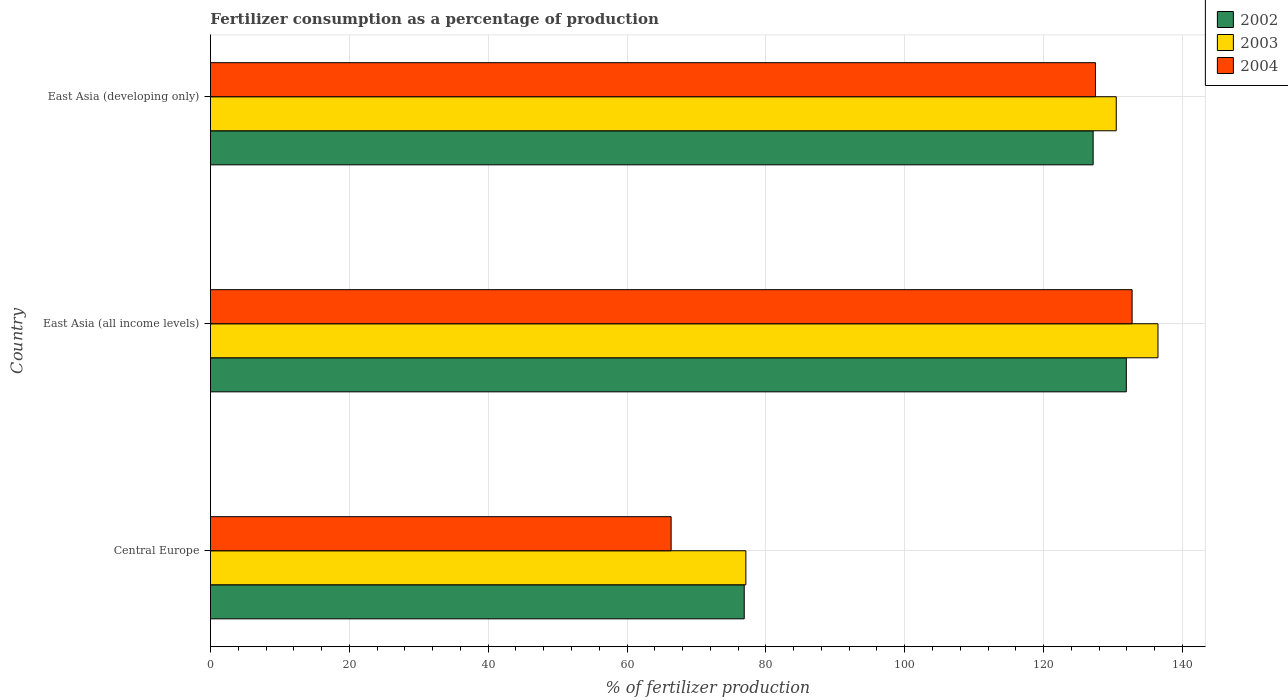How many groups of bars are there?
Offer a terse response. 3. Are the number of bars on each tick of the Y-axis equal?
Your answer should be very brief. Yes. How many bars are there on the 1st tick from the bottom?
Give a very brief answer. 3. What is the label of the 2nd group of bars from the top?
Offer a very short reply. East Asia (all income levels). In how many cases, is the number of bars for a given country not equal to the number of legend labels?
Provide a short and direct response. 0. What is the percentage of fertilizers consumed in 2003 in East Asia (all income levels)?
Keep it short and to the point. 136.48. Across all countries, what is the maximum percentage of fertilizers consumed in 2004?
Offer a very short reply. 132.75. Across all countries, what is the minimum percentage of fertilizers consumed in 2002?
Ensure brevity in your answer.  76.88. In which country was the percentage of fertilizers consumed in 2002 maximum?
Your answer should be compact. East Asia (all income levels). In which country was the percentage of fertilizers consumed in 2004 minimum?
Offer a terse response. Central Europe. What is the total percentage of fertilizers consumed in 2004 in the graph?
Provide a succinct answer. 326.57. What is the difference between the percentage of fertilizers consumed in 2004 in Central Europe and that in East Asia (all income levels)?
Give a very brief answer. -66.4. What is the difference between the percentage of fertilizers consumed in 2004 in East Asia (all income levels) and the percentage of fertilizers consumed in 2002 in East Asia (developing only)?
Ensure brevity in your answer.  5.61. What is the average percentage of fertilizers consumed in 2002 per country?
Offer a very short reply. 111.98. What is the difference between the percentage of fertilizers consumed in 2002 and percentage of fertilizers consumed in 2004 in Central Europe?
Provide a short and direct response. 10.53. In how many countries, is the percentage of fertilizers consumed in 2003 greater than 124 %?
Your response must be concise. 2. What is the ratio of the percentage of fertilizers consumed in 2002 in Central Europe to that in East Asia (all income levels)?
Keep it short and to the point. 0.58. Is the difference between the percentage of fertilizers consumed in 2002 in East Asia (all income levels) and East Asia (developing only) greater than the difference between the percentage of fertilizers consumed in 2004 in East Asia (all income levels) and East Asia (developing only)?
Make the answer very short. No. What is the difference between the highest and the second highest percentage of fertilizers consumed in 2004?
Keep it short and to the point. 5.28. What is the difference between the highest and the lowest percentage of fertilizers consumed in 2003?
Provide a short and direct response. 59.36. Is the sum of the percentage of fertilizers consumed in 2004 in East Asia (all income levels) and East Asia (developing only) greater than the maximum percentage of fertilizers consumed in 2003 across all countries?
Your answer should be compact. Yes. What does the 1st bar from the bottom in Central Europe represents?
Offer a very short reply. 2002. How many bars are there?
Keep it short and to the point. 9. Are the values on the major ticks of X-axis written in scientific E-notation?
Offer a very short reply. No. Does the graph contain grids?
Your response must be concise. Yes. Where does the legend appear in the graph?
Keep it short and to the point. Top right. What is the title of the graph?
Provide a short and direct response. Fertilizer consumption as a percentage of production. What is the label or title of the X-axis?
Offer a very short reply. % of fertilizer production. What is the label or title of the Y-axis?
Provide a short and direct response. Country. What is the % of fertilizer production of 2002 in Central Europe?
Offer a very short reply. 76.88. What is the % of fertilizer production of 2003 in Central Europe?
Offer a very short reply. 77.12. What is the % of fertilizer production of 2004 in Central Europe?
Your answer should be compact. 66.35. What is the % of fertilizer production of 2002 in East Asia (all income levels)?
Make the answer very short. 131.91. What is the % of fertilizer production in 2003 in East Asia (all income levels)?
Offer a terse response. 136.48. What is the % of fertilizer production in 2004 in East Asia (all income levels)?
Provide a succinct answer. 132.75. What is the % of fertilizer production in 2002 in East Asia (developing only)?
Offer a terse response. 127.14. What is the % of fertilizer production in 2003 in East Asia (developing only)?
Keep it short and to the point. 130.46. What is the % of fertilizer production in 2004 in East Asia (developing only)?
Make the answer very short. 127.47. Across all countries, what is the maximum % of fertilizer production of 2002?
Offer a terse response. 131.91. Across all countries, what is the maximum % of fertilizer production of 2003?
Your answer should be very brief. 136.48. Across all countries, what is the maximum % of fertilizer production of 2004?
Provide a short and direct response. 132.75. Across all countries, what is the minimum % of fertilizer production of 2002?
Your answer should be very brief. 76.88. Across all countries, what is the minimum % of fertilizer production in 2003?
Keep it short and to the point. 77.12. Across all countries, what is the minimum % of fertilizer production in 2004?
Give a very brief answer. 66.35. What is the total % of fertilizer production in 2002 in the graph?
Provide a short and direct response. 335.93. What is the total % of fertilizer production in 2003 in the graph?
Your response must be concise. 344.06. What is the total % of fertilizer production of 2004 in the graph?
Offer a terse response. 326.57. What is the difference between the % of fertilizer production of 2002 in Central Europe and that in East Asia (all income levels)?
Offer a terse response. -55.03. What is the difference between the % of fertilizer production in 2003 in Central Europe and that in East Asia (all income levels)?
Offer a terse response. -59.36. What is the difference between the % of fertilizer production of 2004 in Central Europe and that in East Asia (all income levels)?
Your answer should be compact. -66.4. What is the difference between the % of fertilizer production in 2002 in Central Europe and that in East Asia (developing only)?
Keep it short and to the point. -50.26. What is the difference between the % of fertilizer production in 2003 in Central Europe and that in East Asia (developing only)?
Make the answer very short. -53.35. What is the difference between the % of fertilizer production in 2004 in Central Europe and that in East Asia (developing only)?
Provide a short and direct response. -61.12. What is the difference between the % of fertilizer production of 2002 in East Asia (all income levels) and that in East Asia (developing only)?
Offer a very short reply. 4.78. What is the difference between the % of fertilizer production of 2003 in East Asia (all income levels) and that in East Asia (developing only)?
Your answer should be compact. 6.01. What is the difference between the % of fertilizer production of 2004 in East Asia (all income levels) and that in East Asia (developing only)?
Provide a short and direct response. 5.28. What is the difference between the % of fertilizer production in 2002 in Central Europe and the % of fertilizer production in 2003 in East Asia (all income levels)?
Provide a short and direct response. -59.6. What is the difference between the % of fertilizer production of 2002 in Central Europe and the % of fertilizer production of 2004 in East Asia (all income levels)?
Your response must be concise. -55.87. What is the difference between the % of fertilizer production of 2003 in Central Europe and the % of fertilizer production of 2004 in East Asia (all income levels)?
Give a very brief answer. -55.63. What is the difference between the % of fertilizer production of 2002 in Central Europe and the % of fertilizer production of 2003 in East Asia (developing only)?
Your answer should be very brief. -53.58. What is the difference between the % of fertilizer production in 2002 in Central Europe and the % of fertilizer production in 2004 in East Asia (developing only)?
Give a very brief answer. -50.59. What is the difference between the % of fertilizer production of 2003 in Central Europe and the % of fertilizer production of 2004 in East Asia (developing only)?
Ensure brevity in your answer.  -50.35. What is the difference between the % of fertilizer production of 2002 in East Asia (all income levels) and the % of fertilizer production of 2003 in East Asia (developing only)?
Ensure brevity in your answer.  1.45. What is the difference between the % of fertilizer production of 2002 in East Asia (all income levels) and the % of fertilizer production of 2004 in East Asia (developing only)?
Your answer should be compact. 4.44. What is the difference between the % of fertilizer production of 2003 in East Asia (all income levels) and the % of fertilizer production of 2004 in East Asia (developing only)?
Keep it short and to the point. 9.01. What is the average % of fertilizer production in 2002 per country?
Your answer should be compact. 111.98. What is the average % of fertilizer production in 2003 per country?
Keep it short and to the point. 114.69. What is the average % of fertilizer production in 2004 per country?
Your response must be concise. 108.86. What is the difference between the % of fertilizer production of 2002 and % of fertilizer production of 2003 in Central Europe?
Make the answer very short. -0.24. What is the difference between the % of fertilizer production of 2002 and % of fertilizer production of 2004 in Central Europe?
Offer a terse response. 10.53. What is the difference between the % of fertilizer production of 2003 and % of fertilizer production of 2004 in Central Europe?
Your response must be concise. 10.77. What is the difference between the % of fertilizer production of 2002 and % of fertilizer production of 2003 in East Asia (all income levels)?
Provide a succinct answer. -4.56. What is the difference between the % of fertilizer production of 2002 and % of fertilizer production of 2004 in East Asia (all income levels)?
Make the answer very short. -0.84. What is the difference between the % of fertilizer production of 2003 and % of fertilizer production of 2004 in East Asia (all income levels)?
Your response must be concise. 3.73. What is the difference between the % of fertilizer production in 2002 and % of fertilizer production in 2003 in East Asia (developing only)?
Your response must be concise. -3.33. What is the difference between the % of fertilizer production of 2002 and % of fertilizer production of 2004 in East Asia (developing only)?
Give a very brief answer. -0.33. What is the difference between the % of fertilizer production in 2003 and % of fertilizer production in 2004 in East Asia (developing only)?
Your answer should be compact. 3. What is the ratio of the % of fertilizer production of 2002 in Central Europe to that in East Asia (all income levels)?
Provide a short and direct response. 0.58. What is the ratio of the % of fertilizer production of 2003 in Central Europe to that in East Asia (all income levels)?
Keep it short and to the point. 0.57. What is the ratio of the % of fertilizer production in 2004 in Central Europe to that in East Asia (all income levels)?
Provide a short and direct response. 0.5. What is the ratio of the % of fertilizer production of 2002 in Central Europe to that in East Asia (developing only)?
Your response must be concise. 0.6. What is the ratio of the % of fertilizer production of 2003 in Central Europe to that in East Asia (developing only)?
Give a very brief answer. 0.59. What is the ratio of the % of fertilizer production in 2004 in Central Europe to that in East Asia (developing only)?
Give a very brief answer. 0.52. What is the ratio of the % of fertilizer production of 2002 in East Asia (all income levels) to that in East Asia (developing only)?
Give a very brief answer. 1.04. What is the ratio of the % of fertilizer production of 2003 in East Asia (all income levels) to that in East Asia (developing only)?
Offer a very short reply. 1.05. What is the ratio of the % of fertilizer production in 2004 in East Asia (all income levels) to that in East Asia (developing only)?
Offer a terse response. 1.04. What is the difference between the highest and the second highest % of fertilizer production of 2002?
Keep it short and to the point. 4.78. What is the difference between the highest and the second highest % of fertilizer production of 2003?
Keep it short and to the point. 6.01. What is the difference between the highest and the second highest % of fertilizer production of 2004?
Offer a terse response. 5.28. What is the difference between the highest and the lowest % of fertilizer production of 2002?
Offer a terse response. 55.03. What is the difference between the highest and the lowest % of fertilizer production in 2003?
Your answer should be very brief. 59.36. What is the difference between the highest and the lowest % of fertilizer production of 2004?
Provide a succinct answer. 66.4. 